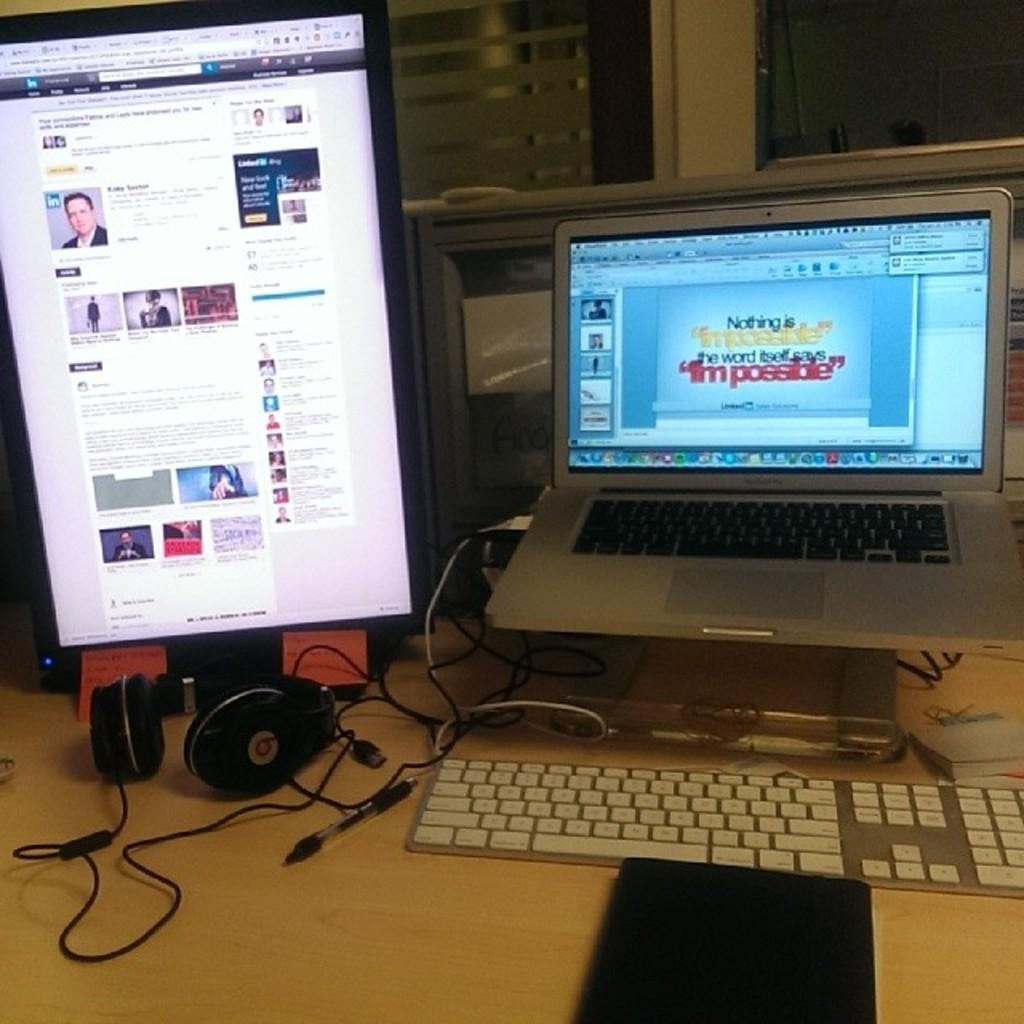<image>
Share a concise interpretation of the image provided. A laptop screen has the word Nothing on it. 